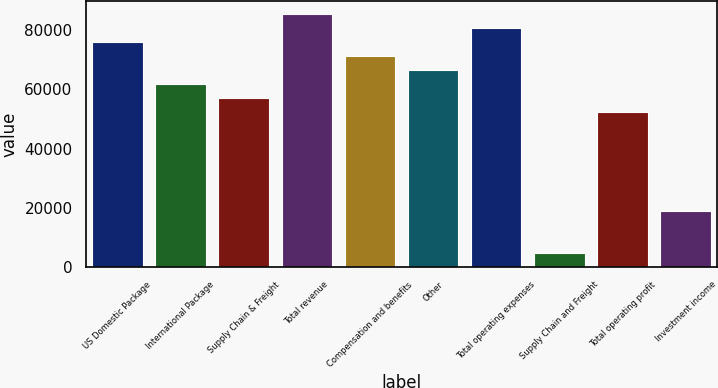<chart> <loc_0><loc_0><loc_500><loc_500><bar_chart><fcel>US Domestic Package<fcel>International Package<fcel>Supply Chain & Freight<fcel>Total revenue<fcel>Compensation and benefits<fcel>Other<fcel>Total operating expenses<fcel>Supply Chain and Freight<fcel>Total operating profit<fcel>Investment income<nl><fcel>76074.3<fcel>61810.7<fcel>57056.1<fcel>85583.4<fcel>71319.8<fcel>66565.2<fcel>80828.9<fcel>4756.07<fcel>52301.6<fcel>19019.7<nl></chart> 